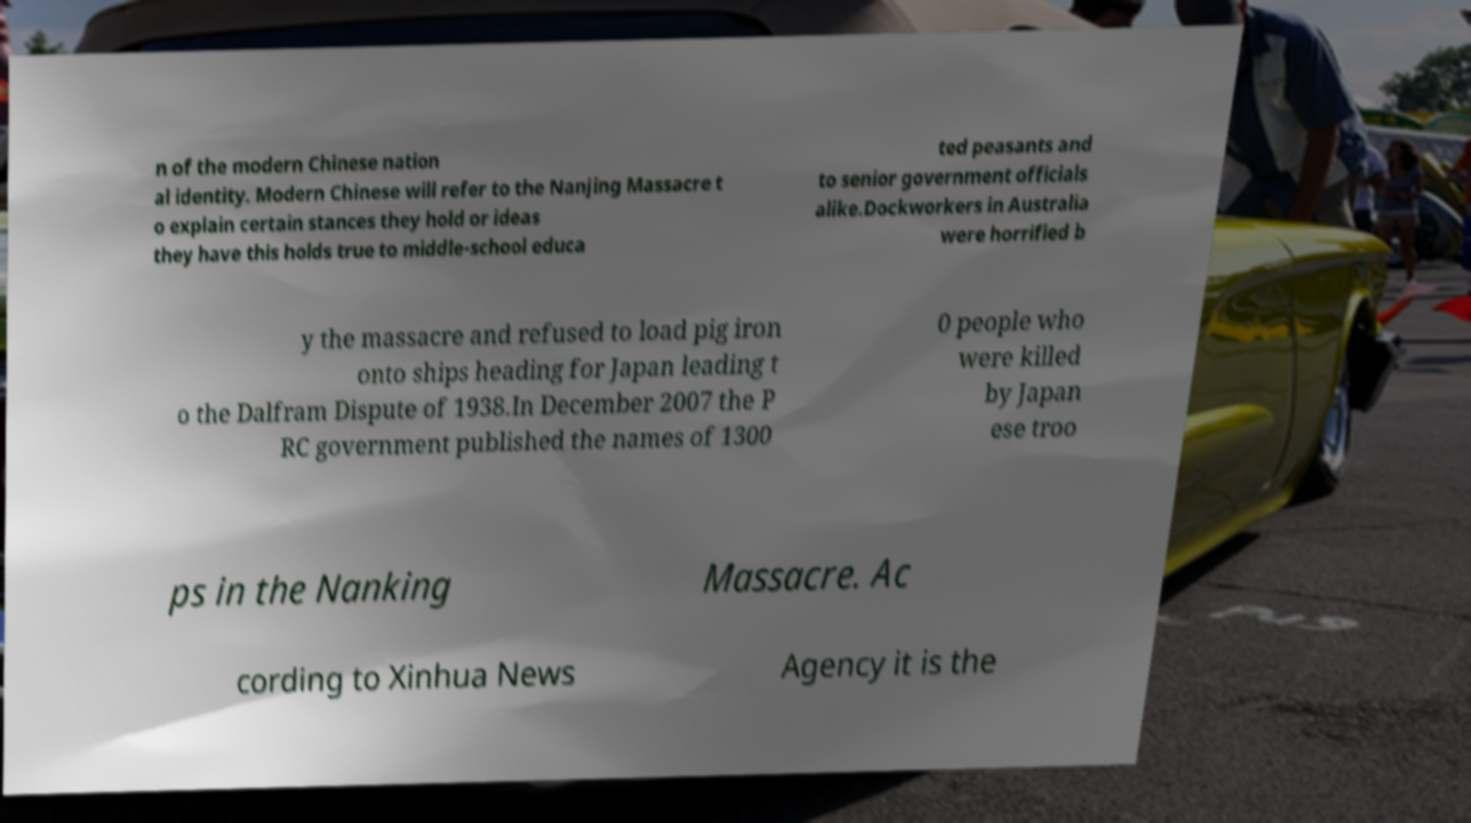Can you accurately transcribe the text from the provided image for me? n of the modern Chinese nation al identity. Modern Chinese will refer to the Nanjing Massacre t o explain certain stances they hold or ideas they have this holds true to middle-school educa ted peasants and to senior government officials alike.Dockworkers in Australia were horrified b y the massacre and refused to load pig iron onto ships heading for Japan leading t o the Dalfram Dispute of 1938.In December 2007 the P RC government published the names of 1300 0 people who were killed by Japan ese troo ps in the Nanking Massacre. Ac cording to Xinhua News Agency it is the 